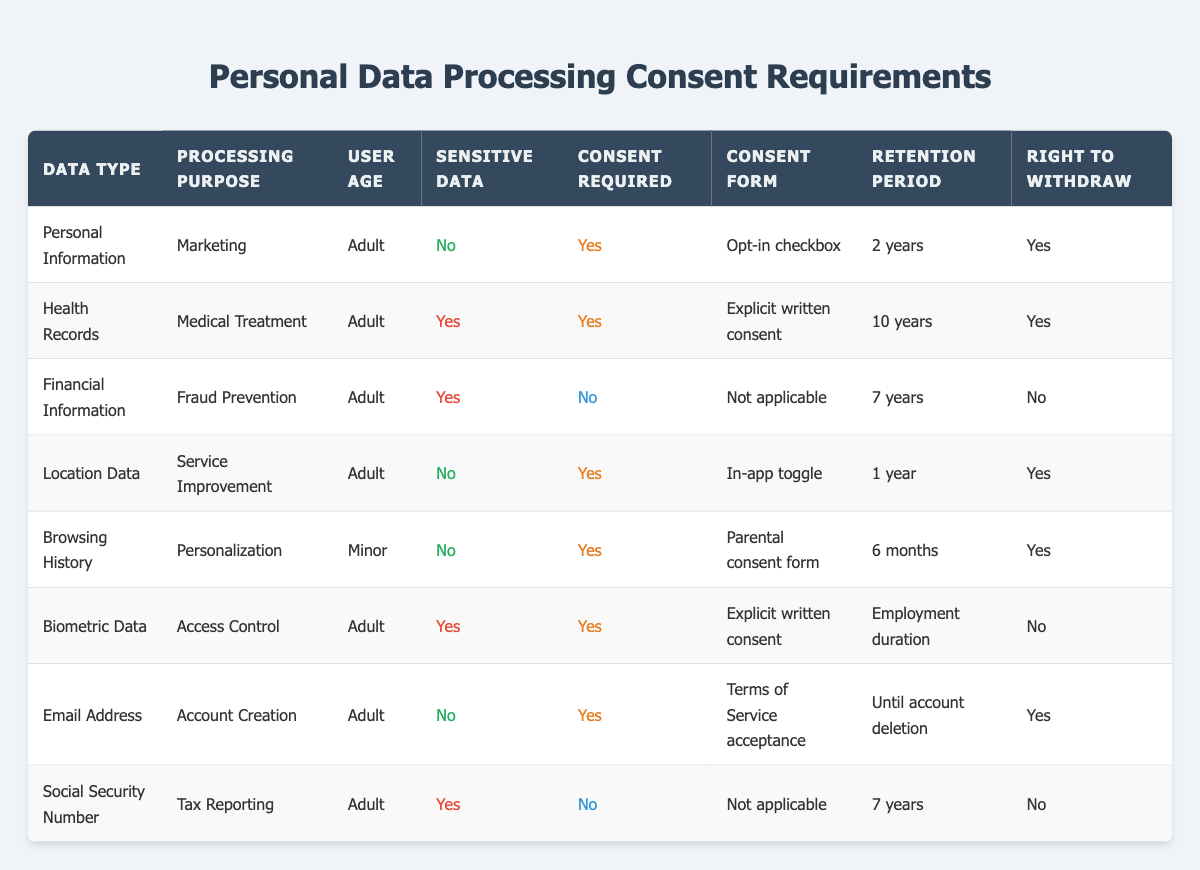What type of consent is required for processing Personal Information for marketing? The table states that for Personal Information processed for marketing, the consent required is "Opt-in checkbox."
Answer: Opt-in checkbox Does processing Health Records for Medical Treatment require consent? According to the table, Health Records for Medical Treatment do require consent, indicated by "Yes" in the consent required column.
Answer: Yes How long is Location Data retained? The table specifies that Location Data is retained for a period of "1 year."
Answer: 1 year How many sensitive data types require explicit consent? There are two sensitive data types in the table that require explicit consent: Health Records and Biometric Data.
Answer: 2 Is there any data type that does not require consent for processing? The table shows that Financial Information and Social Security Number both do not require consent for their respective processing purposes, indicated by "No" in the consent required column.
Answer: Yes What is the retention period for Email Address and can consent be withdrawn? The retention period for Email Address is "Until account deletion," and the right to withdraw consent is present, indicated by "Yes" in the right to withdraw column.
Answer: Until account deletion, Yes What are the types of data for which parental consent is required? The table indicates that parental consent is specifically required for Browsing History, which is associated with minors, as stated in the user age column.
Answer: Browsing History How many data types are processed without requiring consent? There are two data types that do not require consent for processing: Financial Information and Social Security Number, as indicated by "No" in the consent required column.
Answer: 2 Under what conditions can consent be withdrawn for Biometric Data? For Biometric Data, consent cannot be withdrawn, as indicated by "No" in the right to withdraw column in the table.
Answer: No What retention period is specified for Health Records in relation to consent? The table specifies that Health Records are retained for "10 years," which is a significant duration linked with the requirement for explicit written consent.
Answer: 10 years 